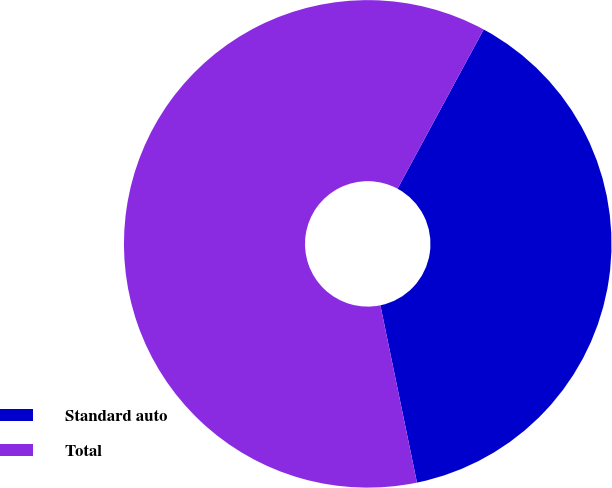<chart> <loc_0><loc_0><loc_500><loc_500><pie_chart><fcel>Standard auto<fcel>Total<nl><fcel>38.87%<fcel>61.13%<nl></chart> 